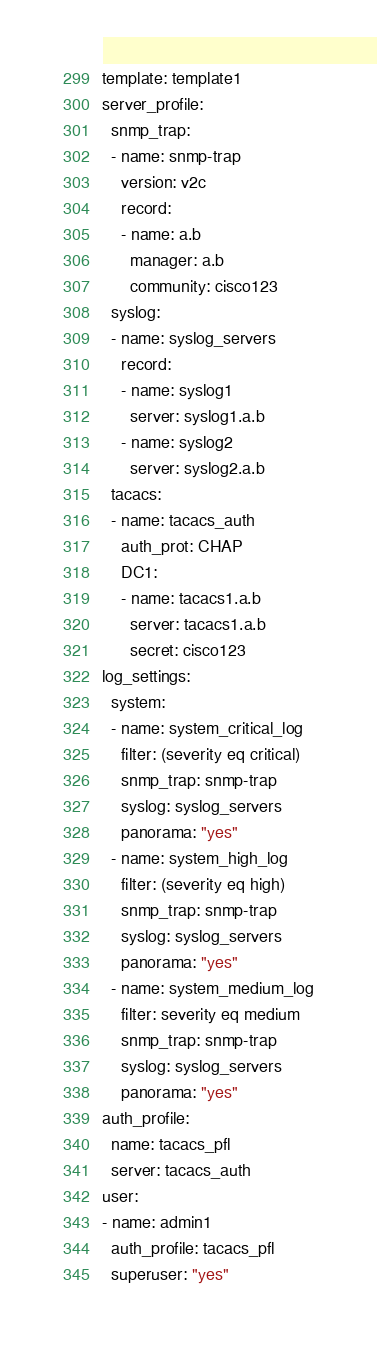Convert code to text. <code><loc_0><loc_0><loc_500><loc_500><_YAML_>template: template1
server_profile:
  snmp_trap:
  - name: snmp-trap
    version: v2c
    record:
    - name: a.b
      manager: a.b
      community: cisco123
  syslog:
  - name: syslog_servers
    record:
    - name: syslog1
      server: syslog1.a.b
    - name: syslog2
      server: syslog2.a.b
  tacacs:
  - name: tacacs_auth
    auth_prot: CHAP
    DC1:
    - name: tacacs1.a.b
      server: tacacs1.a.b
      secret: cisco123
log_settings:
  system:
  - name: system_critical_log
    filter: (severity eq critical)
    snmp_trap: snmp-trap
    syslog: syslog_servers
    panorama: "yes"
  - name: system_high_log
    filter: (severity eq high)
    snmp_trap: snmp-trap
    syslog: syslog_servers
    panorama: "yes"
  - name: system_medium_log
    filter: severity eq medium
    snmp_trap: snmp-trap
    syslog: syslog_servers
    panorama: "yes"
auth_profile:
  name: tacacs_pfl
  server: tacacs_auth
user:
- name: admin1
  auth_profile: tacacs_pfl
  superuser: "yes"

</code> 